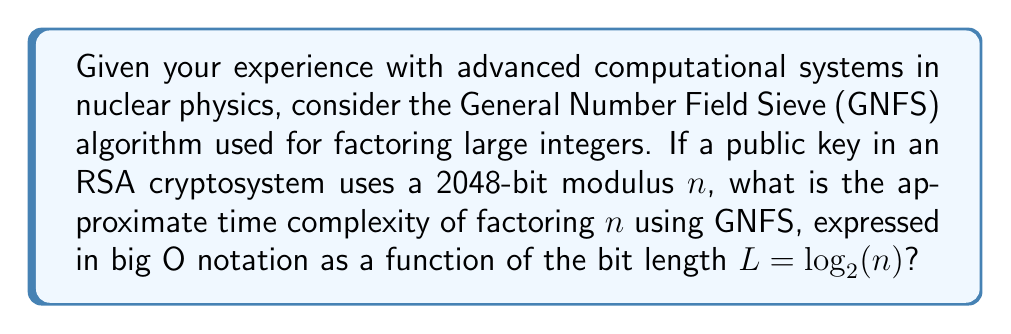Can you solve this math problem? To answer this question, we'll follow these steps:

1) The General Number Field Sieve (GNFS) is currently the most efficient known algorithm for factoring large integers, which is crucial in breaking RSA cryptosystems.

2) The time complexity of GNFS is typically expressed in terms of the bit length of the number to be factored. In this case, $L = \log_2(n) = 2048$.

3) The asymptotic time complexity of GNFS is:

   $$O(\exp((c + o(1))(\ln n)^{1/3}(\ln \ln n)^{2/3}))$$

   where $c$ is a constant approximately equal to $\left(\frac{64}{9}\right)^{1/3} \approx 1.923$.

4) To simplify this expression, we can use $L = \log_2(n)$, which gives us:

   $$O(\exp((c + o(1))(L \ln 2)^{1/3}(\ln(L \ln 2))^{2/3}))$$

5) The $o(1)$ term approaches zero as $n$ (and thus $L$) increases, so for very large $n$, we can approximate the complexity as:

   $$O(\exp(c(L \ln 2)^{1/3}(\ln(L \ln 2))^{2/3}))$$

6) This can be further simplified to:

   $$O(\exp(1.923(L \ln 2)^{1/3}(\ln(L \ln 2))^{2/3}))$$

7) This expression is often approximated in the literature as:

   $$O(\exp(1.923L^{1/3}(\ln L)^{2/3}))$$

This final form is the most commonly used representation of GNFS complexity in terms of the bit length $L$.
Answer: $O(\exp(1.923L^{1/3}(\ln L)^{2/3}))$ 